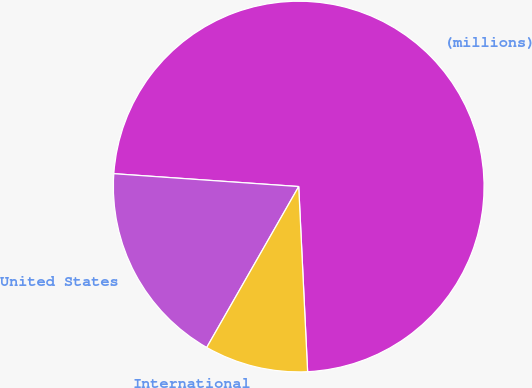Convert chart to OTSL. <chart><loc_0><loc_0><loc_500><loc_500><pie_chart><fcel>(millions)<fcel>United States<fcel>International<nl><fcel>73.13%<fcel>17.84%<fcel>9.03%<nl></chart> 